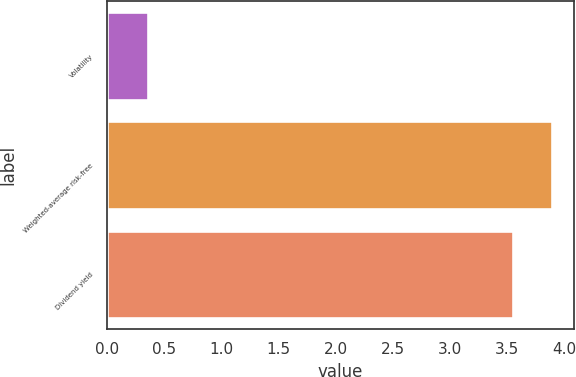Convert chart. <chart><loc_0><loc_0><loc_500><loc_500><bar_chart><fcel>Volatility<fcel>Weighted-average risk-free<fcel>Dividend yield<nl><fcel>0.36<fcel>3.89<fcel>3.55<nl></chart> 